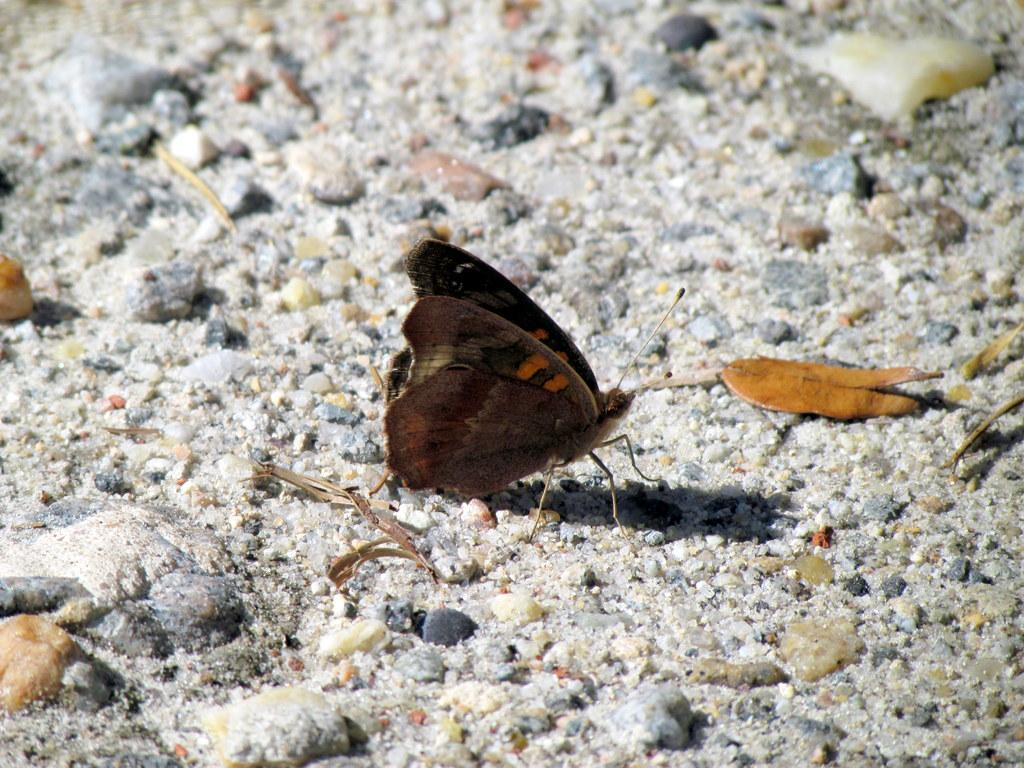What type of creature is present in the image? There is a butterfly in the image. Where is the butterfly located? The butterfly is on the land. What can be found on the land in the image? The land has rocks. What type of road can be seen in the image? There is no road present in the image; it features a butterfly on the land with rocks. What type of fowl is visible in the image? There is no fowl present in the image; it features a butterfly on the land with rocks. 